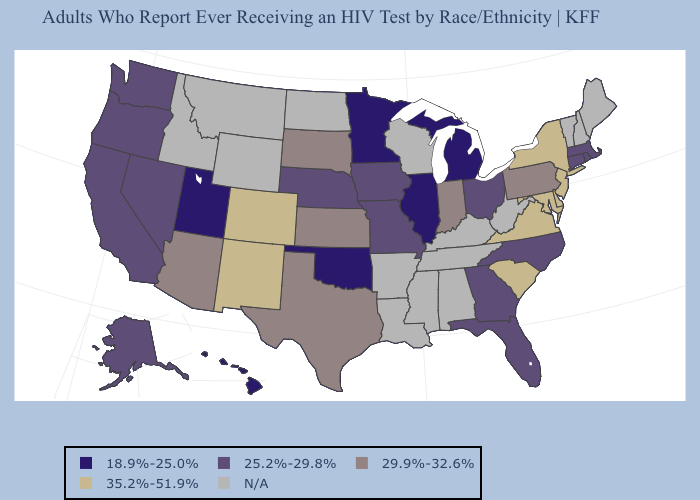What is the value of Maine?
Be succinct. N/A. What is the lowest value in the South?
Concise answer only. 18.9%-25.0%. What is the value of Maryland?
Quick response, please. 35.2%-51.9%. Name the states that have a value in the range 25.2%-29.8%?
Be succinct. Alaska, California, Connecticut, Florida, Georgia, Iowa, Massachusetts, Missouri, Nebraska, Nevada, North Carolina, Ohio, Oregon, Rhode Island, Washington. What is the lowest value in the USA?
Be succinct. 18.9%-25.0%. Name the states that have a value in the range N/A?
Concise answer only. Alabama, Arkansas, Idaho, Kentucky, Louisiana, Maine, Mississippi, Montana, New Hampshire, North Dakota, Tennessee, Vermont, West Virginia, Wisconsin, Wyoming. Name the states that have a value in the range 29.9%-32.6%?
Be succinct. Arizona, Indiana, Kansas, Pennsylvania, South Dakota, Texas. Does the map have missing data?
Concise answer only. Yes. What is the value of Michigan?
Be succinct. 18.9%-25.0%. What is the value of Arizona?
Be succinct. 29.9%-32.6%. Name the states that have a value in the range 25.2%-29.8%?
Give a very brief answer. Alaska, California, Connecticut, Florida, Georgia, Iowa, Massachusetts, Missouri, Nebraska, Nevada, North Carolina, Ohio, Oregon, Rhode Island, Washington. Does the map have missing data?
Quick response, please. Yes. What is the value of Minnesota?
Concise answer only. 18.9%-25.0%. Name the states that have a value in the range 29.9%-32.6%?
Give a very brief answer. Arizona, Indiana, Kansas, Pennsylvania, South Dakota, Texas. Among the states that border New Mexico , which have the lowest value?
Keep it brief. Oklahoma, Utah. 